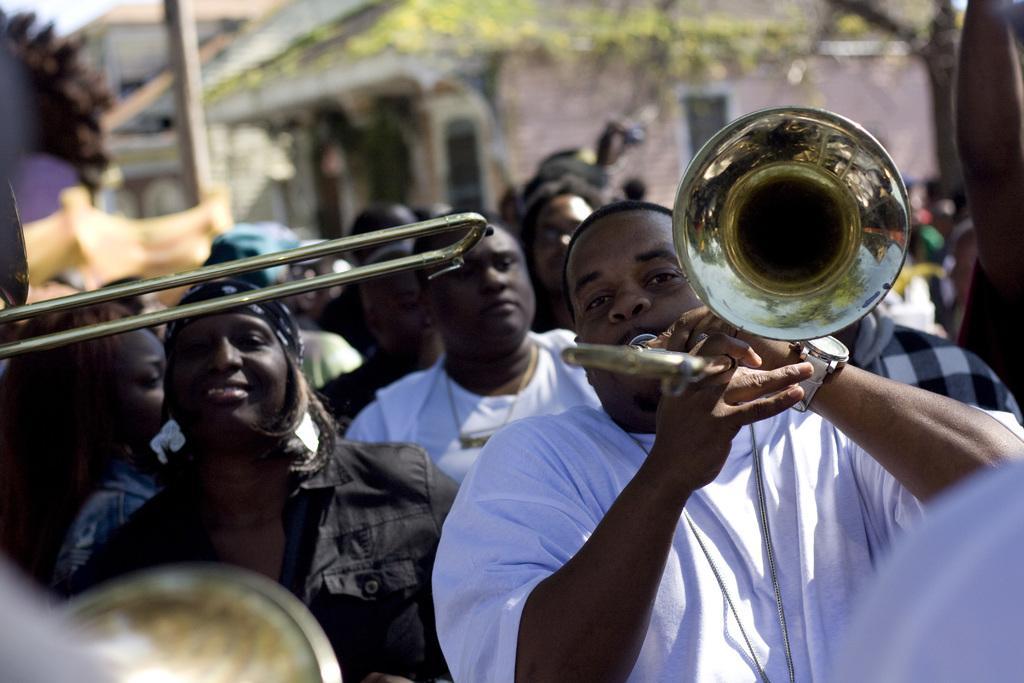Can you describe this image briefly? In this image in front there are two people holding the musical instruments in their hands. Behind them there a few other people. In the background of the image there are buildings, trees. 